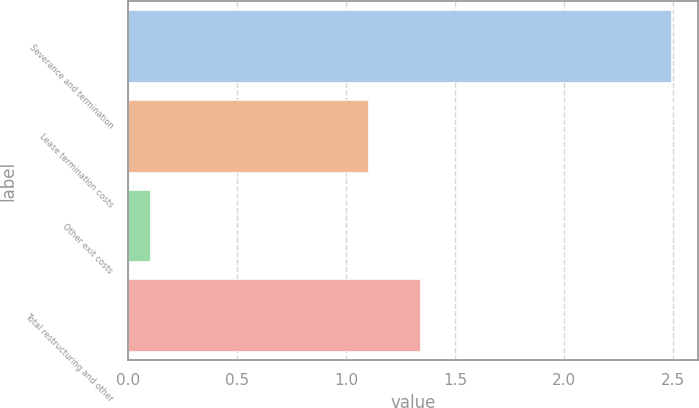Convert chart. <chart><loc_0><loc_0><loc_500><loc_500><bar_chart><fcel>Severance and termination<fcel>Lease termination costs<fcel>Other exit costs<fcel>Total restructuring and other<nl><fcel>2.49<fcel>1.1<fcel>0.1<fcel>1.34<nl></chart> 